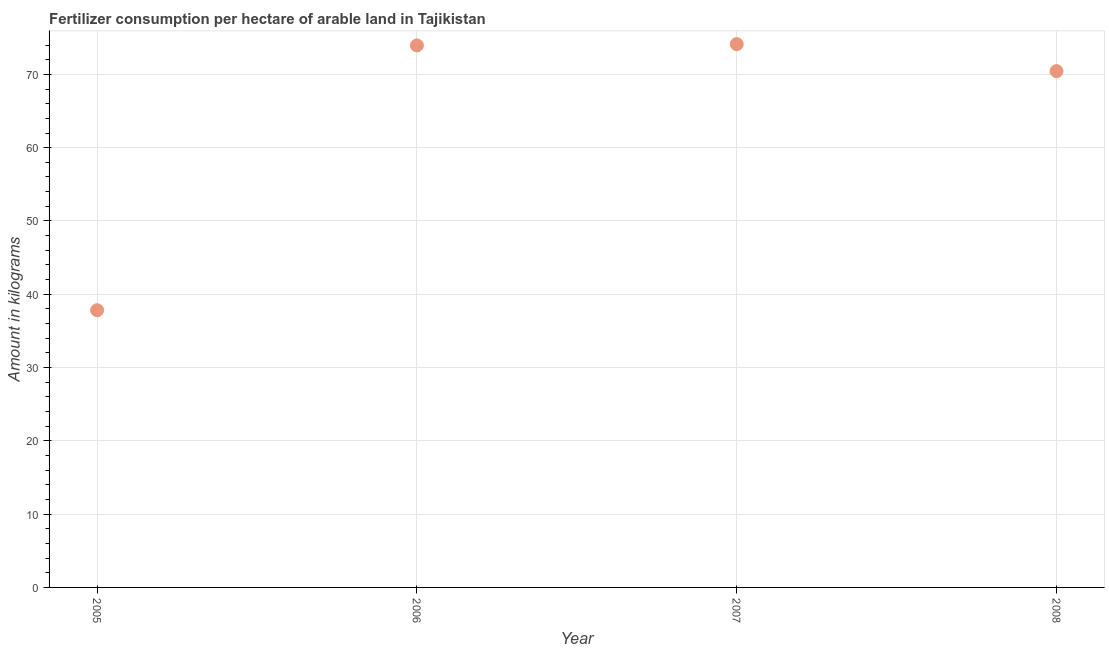What is the amount of fertilizer consumption in 2008?
Your answer should be very brief. 70.45. Across all years, what is the maximum amount of fertilizer consumption?
Your response must be concise. 74.13. Across all years, what is the minimum amount of fertilizer consumption?
Your answer should be very brief. 37.82. In which year was the amount of fertilizer consumption minimum?
Provide a short and direct response. 2005. What is the sum of the amount of fertilizer consumption?
Your answer should be very brief. 256.35. What is the difference between the amount of fertilizer consumption in 2005 and 2006?
Make the answer very short. -36.12. What is the average amount of fertilizer consumption per year?
Ensure brevity in your answer.  64.09. What is the median amount of fertilizer consumption?
Your answer should be compact. 72.2. In how many years, is the amount of fertilizer consumption greater than 56 kg?
Give a very brief answer. 3. Do a majority of the years between 2005 and 2008 (inclusive) have amount of fertilizer consumption greater than 66 kg?
Offer a terse response. Yes. What is the ratio of the amount of fertilizer consumption in 2005 to that in 2007?
Give a very brief answer. 0.51. What is the difference between the highest and the second highest amount of fertilizer consumption?
Offer a terse response. 0.18. What is the difference between the highest and the lowest amount of fertilizer consumption?
Give a very brief answer. 36.3. Does the amount of fertilizer consumption monotonically increase over the years?
Ensure brevity in your answer.  No. How many dotlines are there?
Provide a succinct answer. 1. Does the graph contain grids?
Your response must be concise. Yes. What is the title of the graph?
Provide a succinct answer. Fertilizer consumption per hectare of arable land in Tajikistan . What is the label or title of the Y-axis?
Provide a succinct answer. Amount in kilograms. What is the Amount in kilograms in 2005?
Offer a terse response. 37.82. What is the Amount in kilograms in 2006?
Ensure brevity in your answer.  73.95. What is the Amount in kilograms in 2007?
Provide a succinct answer. 74.13. What is the Amount in kilograms in 2008?
Offer a terse response. 70.45. What is the difference between the Amount in kilograms in 2005 and 2006?
Give a very brief answer. -36.12. What is the difference between the Amount in kilograms in 2005 and 2007?
Provide a short and direct response. -36.3. What is the difference between the Amount in kilograms in 2005 and 2008?
Offer a very short reply. -32.62. What is the difference between the Amount in kilograms in 2006 and 2007?
Provide a short and direct response. -0.18. What is the difference between the Amount in kilograms in 2006 and 2008?
Ensure brevity in your answer.  3.5. What is the difference between the Amount in kilograms in 2007 and 2008?
Offer a very short reply. 3.68. What is the ratio of the Amount in kilograms in 2005 to that in 2006?
Ensure brevity in your answer.  0.51. What is the ratio of the Amount in kilograms in 2005 to that in 2007?
Your answer should be compact. 0.51. What is the ratio of the Amount in kilograms in 2005 to that in 2008?
Provide a succinct answer. 0.54. What is the ratio of the Amount in kilograms in 2006 to that in 2008?
Your answer should be very brief. 1.05. What is the ratio of the Amount in kilograms in 2007 to that in 2008?
Your answer should be compact. 1.05. 